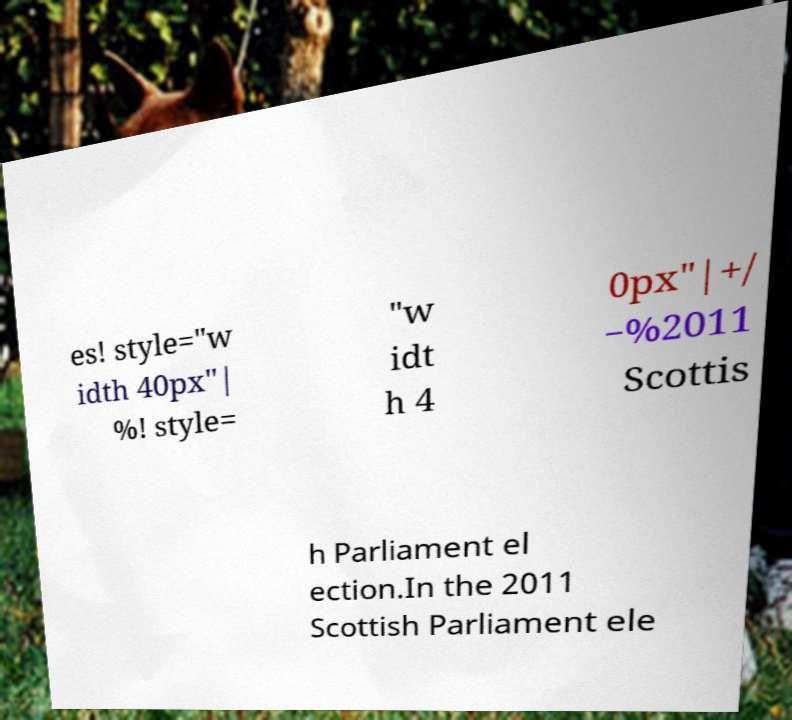For documentation purposes, I need the text within this image transcribed. Could you provide that? es! style="w idth 40px"| %! style= "w idt h 4 0px"|+/ −%2011 Scottis h Parliament el ection.In the 2011 Scottish Parliament ele 